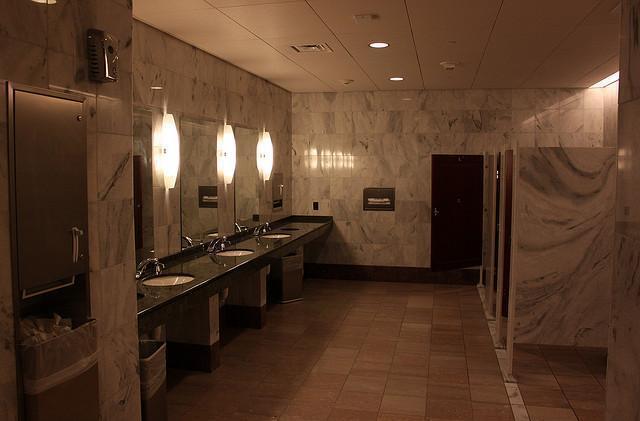What material is the tile for the walls and stalls of this bathroom?
Answer the question by selecting the correct answer among the 4 following choices.
Options: Porcelain, plastic, marble, laminate. Marble. Where might this bathroom be?
Pick the correct solution from the four options below to address the question.
Options: School, casino, library, house. Casino. 